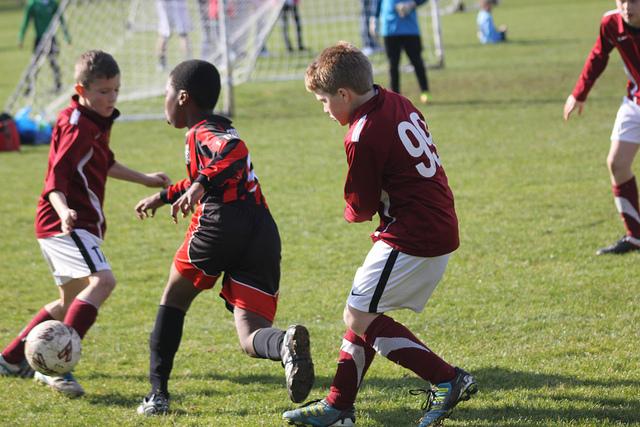What is the only full Jersey number visible?
Write a very short answer. 99. How many legs are visible in the picture?
Concise answer only. 7. How many team members with the yellow shirts can be seen?
Be succinct. 0. What sport is the boy playing?
Quick response, please. Soccer. How old are the boys?
Write a very short answer. 10. Who is he playing with?
Quick response, please. Kids. What are these boys playing?
Quick response, please. Soccer. 